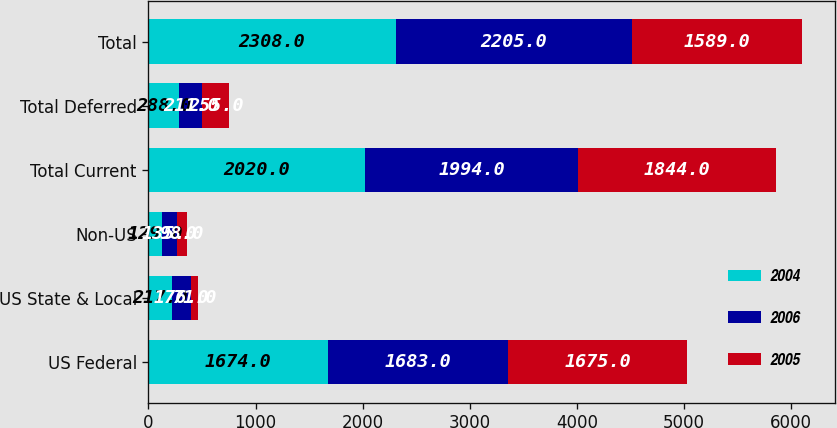<chart> <loc_0><loc_0><loc_500><loc_500><stacked_bar_chart><ecel><fcel>US Federal<fcel>US State & Local<fcel>Non-US<fcel>Total Current<fcel>Total Deferred<fcel>Total<nl><fcel>2004<fcel>1674<fcel>217<fcel>129<fcel>2020<fcel>288<fcel>2308<nl><fcel>2006<fcel>1683<fcel>176<fcel>135<fcel>1994<fcel>211<fcel>2205<nl><fcel>2005<fcel>1675<fcel>71<fcel>98<fcel>1844<fcel>255<fcel>1589<nl></chart> 